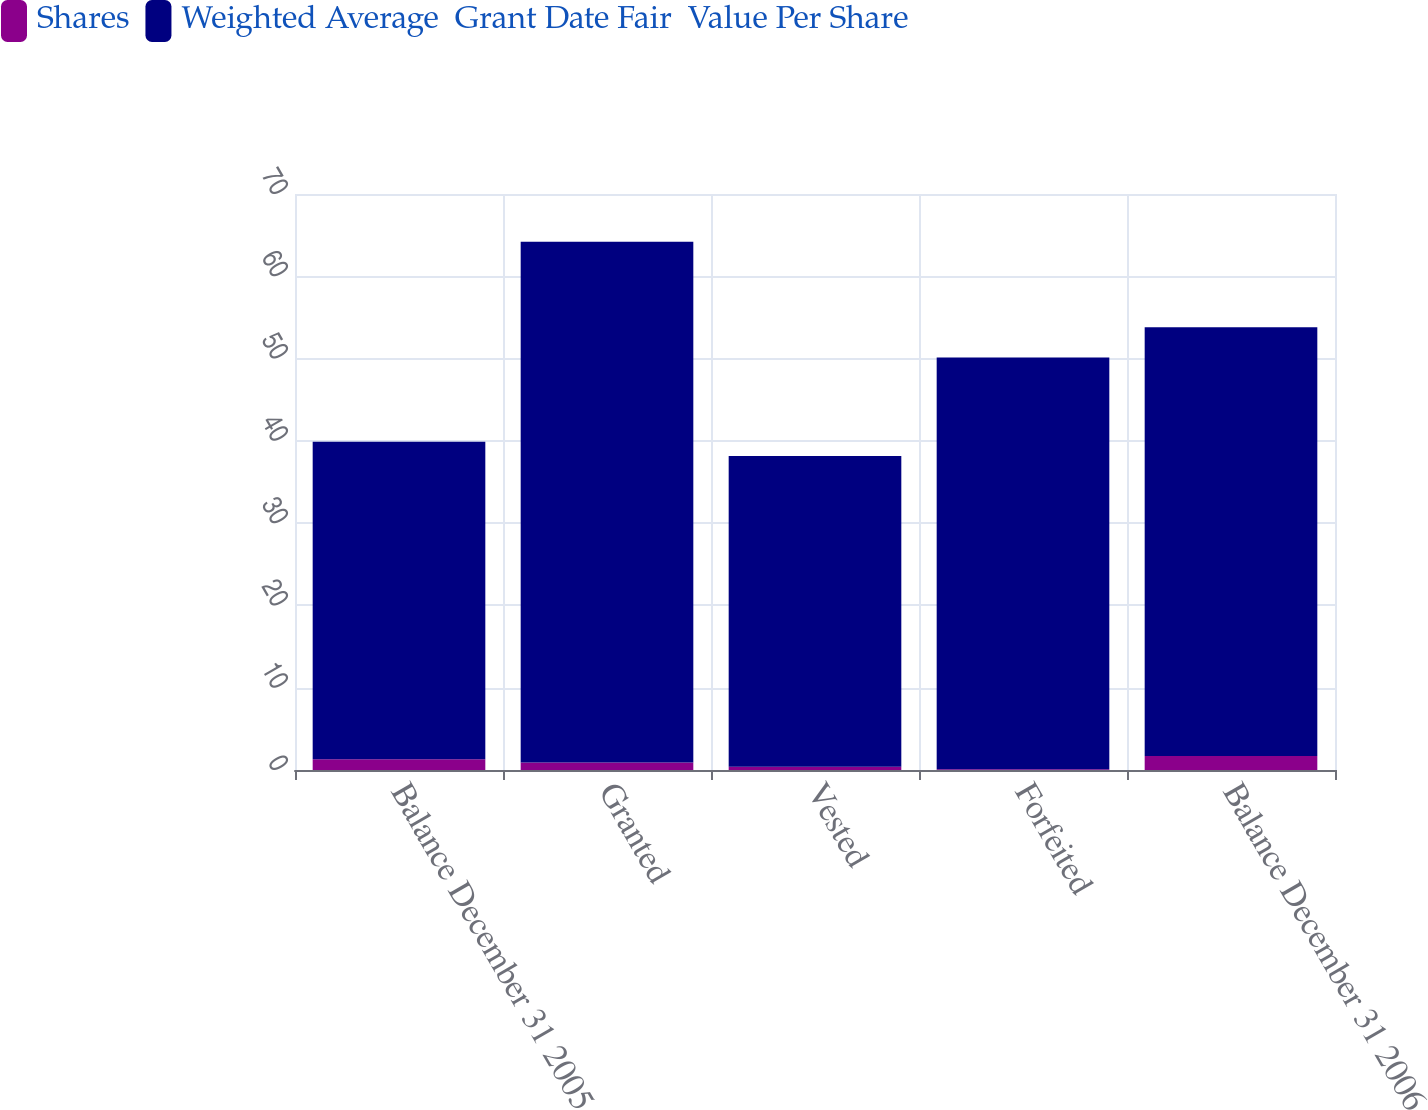<chart> <loc_0><loc_0><loc_500><loc_500><stacked_bar_chart><ecel><fcel>Balance December 31 2005<fcel>Granted<fcel>Vested<fcel>Forfeited<fcel>Balance December 31 2006<nl><fcel>Shares<fcel>1.3<fcel>0.9<fcel>0.4<fcel>0.1<fcel>1.7<nl><fcel>Weighted Average  Grant Date Fair  Value Per Share<fcel>38.59<fcel>63.31<fcel>37.76<fcel>50.03<fcel>52.12<nl></chart> 